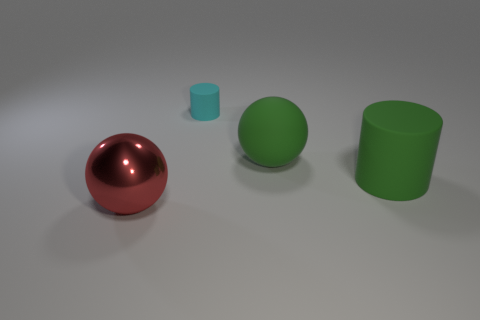Add 3 red metallic spheres. How many objects exist? 7 Subtract 1 spheres. How many spheres are left? 1 Add 4 green objects. How many green objects exist? 6 Subtract 0 gray blocks. How many objects are left? 4 Subtract all yellow balls. Subtract all green cylinders. How many balls are left? 2 Subtract all large green matte balls. Subtract all small matte objects. How many objects are left? 2 Add 3 metallic balls. How many metallic balls are left? 4 